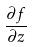<formula> <loc_0><loc_0><loc_500><loc_500>\frac { \partial f } { \partial z }</formula> 